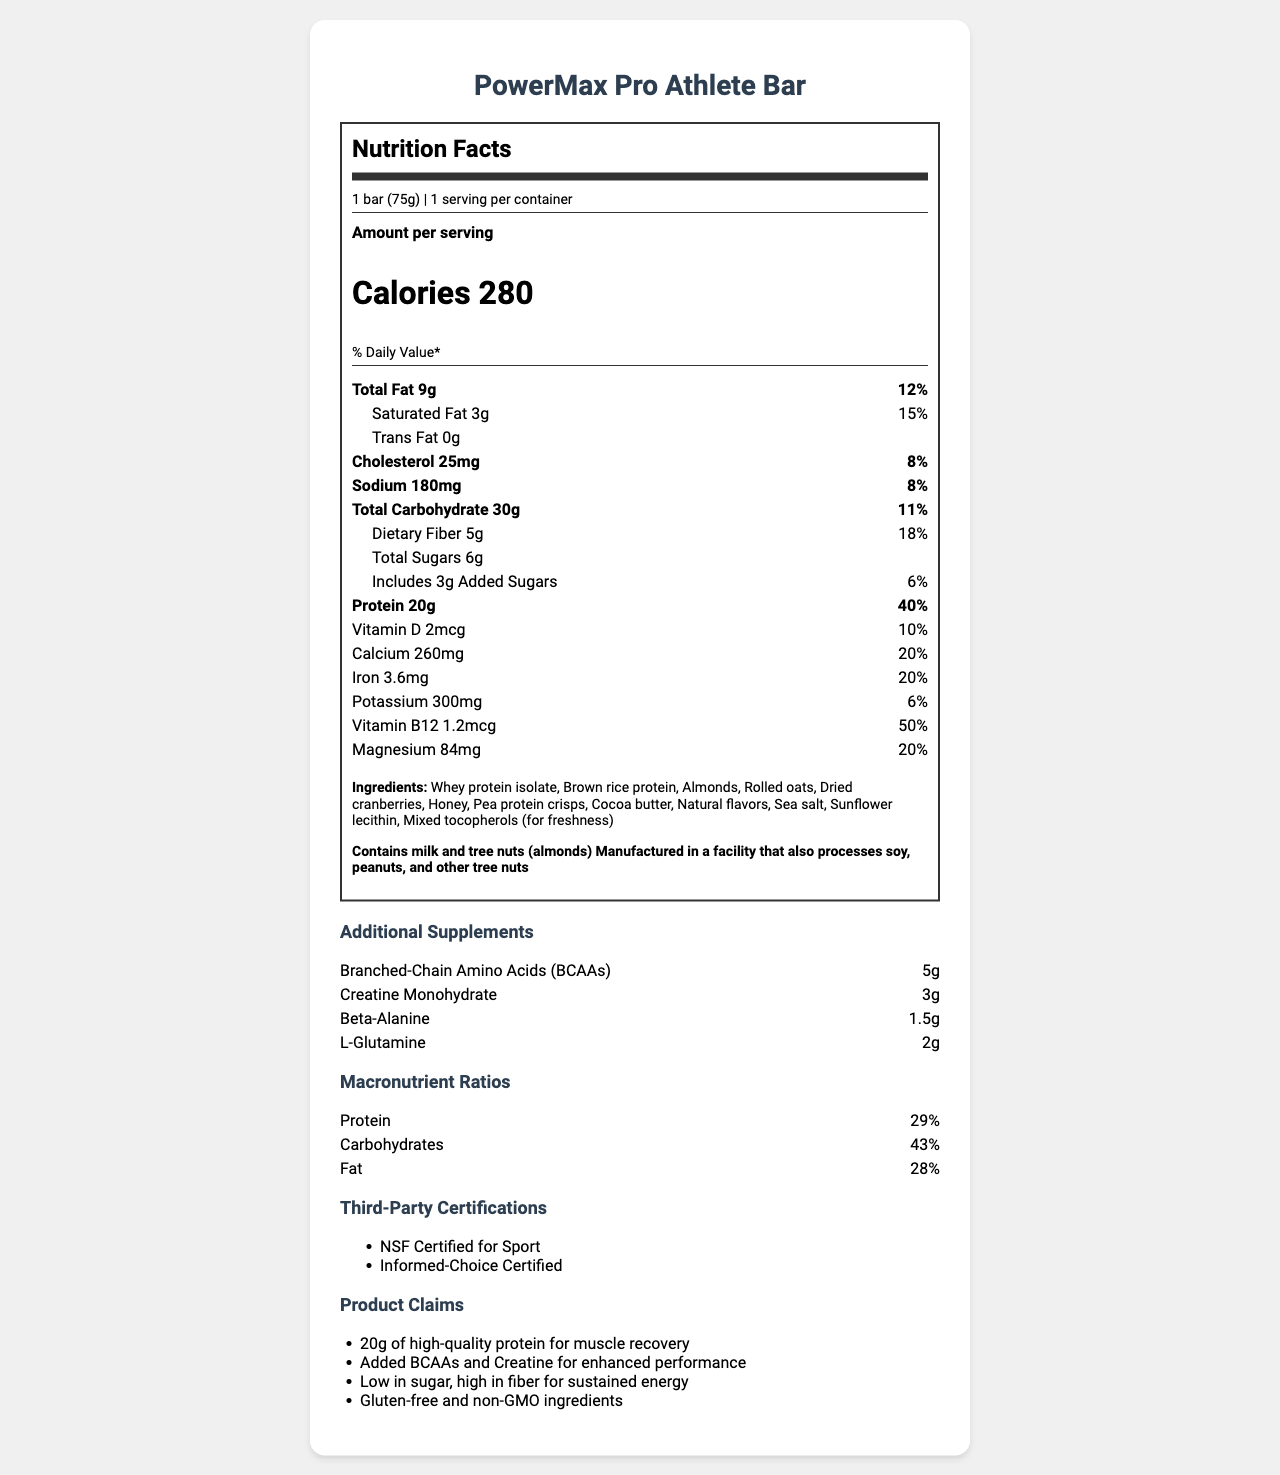what is the serving size of the PowerMax Pro Athlete Bar? The serving size is clearly mentioned in the document as 1 bar (75g).
Answer: 1 bar (75g) how many calories are in one serving? The document states that each serving contains 280 calories.
Answer: 280 what is the amount of protein per serving? The nutrition facts label indicates that there is 20g of protein per serving.
Answer: 20g what is the percentage daily value of magnesium? The document lists the daily value of magnesium as 20%.
Answer: 20% how much dietary fiber is included in the bar? The document specifies that there is 5g of dietary fiber in the bar.
Answer: 5g which allergens are present in the PowerMax Pro Athlete Bar? (Choose all that apply) A. Milk B. Soy C. Peanuts D. Tree Nuts (Almonds) The document notes that the bar contains milk and tree nuts (almonds).
Answer: A, D what are the macronutrient ratios of the PowerMax Pro Athlete Bar? A. 33% protein, 45% carbohydrates, 22% fat B. 29% protein, 43% carbohydrates, 28% fat C. 25% protein, 50% carbohydrates, 25% fat The macronutrient ratios provided in the document are 29% protein, 43% carbohydrates, and 28% fat.
Answer: B does the bar contain gluten? The marketing claims specify that the bar contains gluten-free ingredients.
Answer: No what are the third-party certifications listed for the product? The document states that the product has these two third-party certifications.
Answer: NSF Certified for Sport, Informed-Choice Certified summarize the main nutritional benefits of the PowerMax Pro Athlete Bar. The document highlights these benefits through its nutritional information, added supplements, and marketing claims.
Answer: Key benefits include 20g of high-quality protein for muscle recovery, added supplements like BCAAs and Creatine for enhanced performance, low sugar content, high fiber for sustained energy, and essential vitamins and minerals. how much total fat is in one serving and what is its daily value percentage? The document indicates that the total fat content per serving is 9g, with a daily value percentage of 12%.
Answer: 9g, 12% describe the marketing claims made for the PowerMax Pro Athlete Bar. The document lists specific marketing claims in a dedicated section, mentioning these benefits.
Answer: The claims emphasize 20g of high-quality protein for muscle recovery, added BCAAs and Creatine for enhanced performance, low sugar and high fiber content for sustained energy, and the use of gluten-free and non-GMO ingredients. what is the main ingredient in the PowerMax Pro Athlete Bar? The first ingredient listed in the document is Whey protein isolate, indicating it is the main ingredient.
Answer: Whey protein isolate is there information on the environmental impact of the product's packaging? The document does not provide information regarding the environmental impact of the product's packaging.
Answer: Cannot be determined 